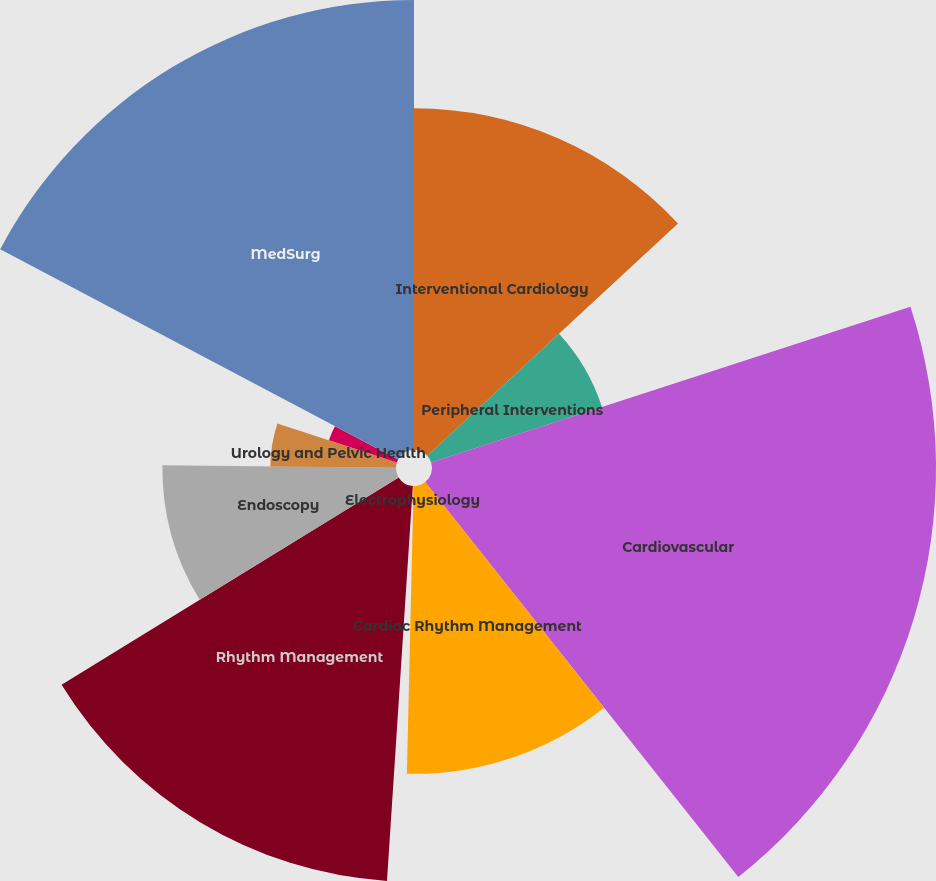Convert chart. <chart><loc_0><loc_0><loc_500><loc_500><pie_chart><fcel>Interventional Cardiology<fcel>Peripheral Interventions<fcel>Cardiovascular<fcel>Cardiac Rhythm Management<fcel>Electrophysiology<fcel>Rhythm Management<fcel>Endoscopy<fcel>Urology and Pelvic Health<fcel>Neuromodulation<fcel>MedSurg<nl><fcel>13.11%<fcel>6.89%<fcel>19.33%<fcel>11.04%<fcel>0.67%<fcel>15.18%<fcel>8.96%<fcel>4.82%<fcel>2.74%<fcel>17.26%<nl></chart> 